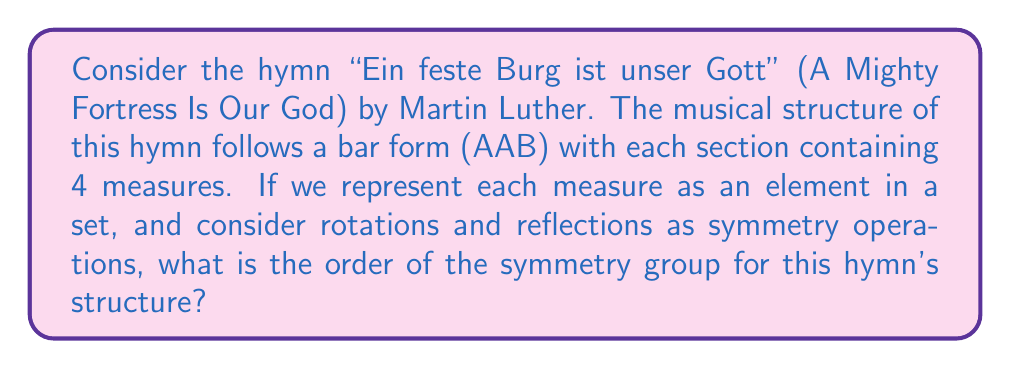Solve this math problem. Let's approach this step-by-step:

1) First, we need to represent the structure of the hymn mathematically. We have:
   A A B, where each letter represents 4 measures.

2) We can consider this as a set of 12 elements: {1, 2, 3, 4, 5, 6, 7, 8, 9, 10, 11, 12}
   Where 1-4 represent the first A, 5-8 the second A, and 9-12 represent B.

3) The symmetry operations we can perform are:
   - Identity (leave as is)
   - Rotation by 120° (shift by 4 elements)
   - Rotation by 240° (shift by 8 elements)
   - Reflection across three axes (between A and A, A and B, B and A)

4) Let's count these symmetries:
   - 1 identity operation
   - 2 rotations (120° and 240°)
   - 3 reflections

5) The total number of symmetry operations is 1 + 2 + 3 = 6

6) In group theory, the number of elements in a group is called its order.

Therefore, the order of the symmetry group for this hymn's structure is 6.

This group is isomorphic to $D_3$, the dihedral group of order 6, which is the symmetry group of an equilateral triangle.
Answer: 6 